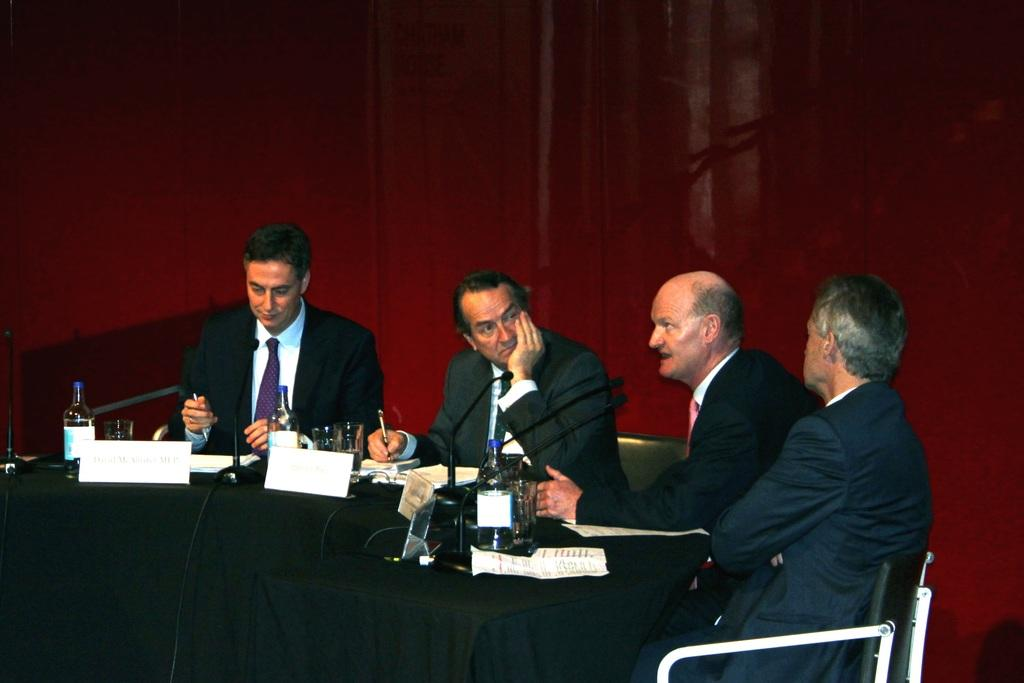How many people are in the image? There is a group of people in the image. What are the people doing in the image? The people are seated on chairs. What objects can be seen on the table in the image? There are bottles and other things visible on the table in the image. What items are used for amplifying sound in the image? Microphones are present in the image. What can be used to identify the people in the image? Name boards are in the image. What type of grip is being used by the people in the image? There is no specific grip being used by the people in the image; they are simply seated on chairs. 